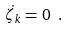Convert formula to latex. <formula><loc_0><loc_0><loc_500><loc_500>\dot { \zeta _ { k } } = 0 \ .</formula> 